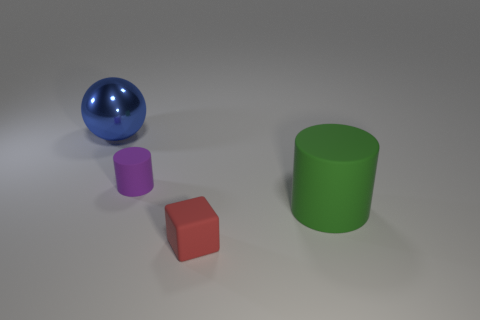Add 3 metal balls. How many objects exist? 7 Subtract all cubes. How many objects are left? 3 Subtract 1 blue spheres. How many objects are left? 3 Subtract all purple matte cylinders. Subtract all tiny brown balls. How many objects are left? 3 Add 2 green cylinders. How many green cylinders are left? 3 Add 4 small gray rubber cylinders. How many small gray rubber cylinders exist? 4 